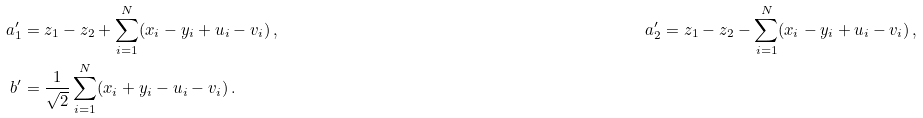Convert formula to latex. <formula><loc_0><loc_0><loc_500><loc_500>a ^ { \prime } _ { 1 } & = z _ { 1 } - z _ { 2 } + \sum _ { i = 1 } ^ { N } ( x _ { i } - y _ { i } + u _ { i } - v _ { i } ) \, , & & & & a ^ { \prime } _ { 2 } = z _ { 1 } - z _ { 2 } - \sum _ { i = 1 } ^ { N } ( x _ { i } - y _ { i } + u _ { i } - v _ { i } ) \, , \\ b ^ { \prime } & = \frac { 1 } { \sqrt { 2 } } \sum _ { i = 1 } ^ { N } ( x _ { i } + y _ { i } - u _ { i } - v _ { i } ) \, .</formula> 